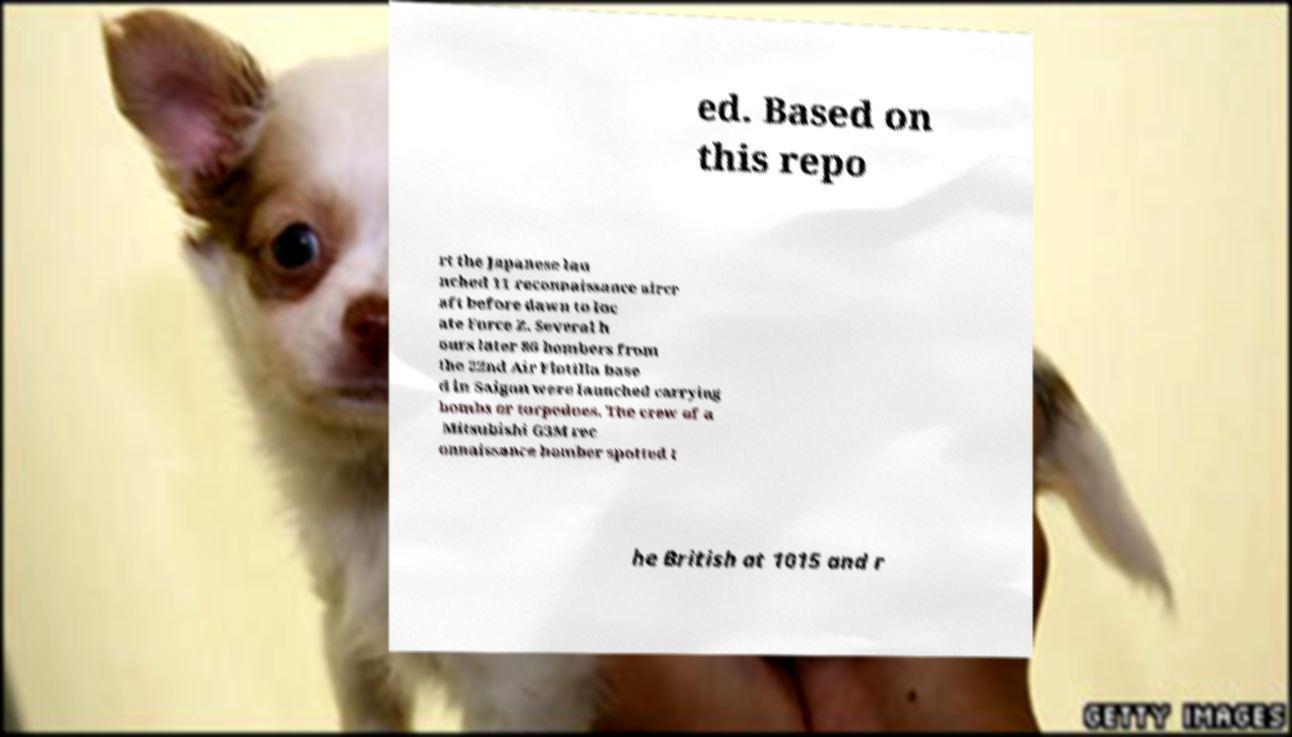I need the written content from this picture converted into text. Can you do that? ed. Based on this repo rt the Japanese lau nched 11 reconnaissance aircr aft before dawn to loc ate Force Z. Several h ours later 86 bombers from the 22nd Air Flotilla base d in Saigon were launched carrying bombs or torpedoes. The crew of a Mitsubishi G3M rec onnaissance bomber spotted t he British at 1015 and r 